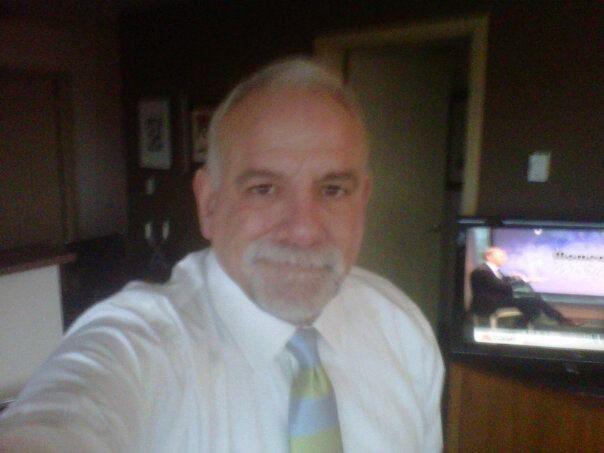How many phones does he have?
Give a very brief answer. 0. How many men's faces are shown?
Give a very brief answer. 1. How many light switches are there?
Give a very brief answer. 1. 